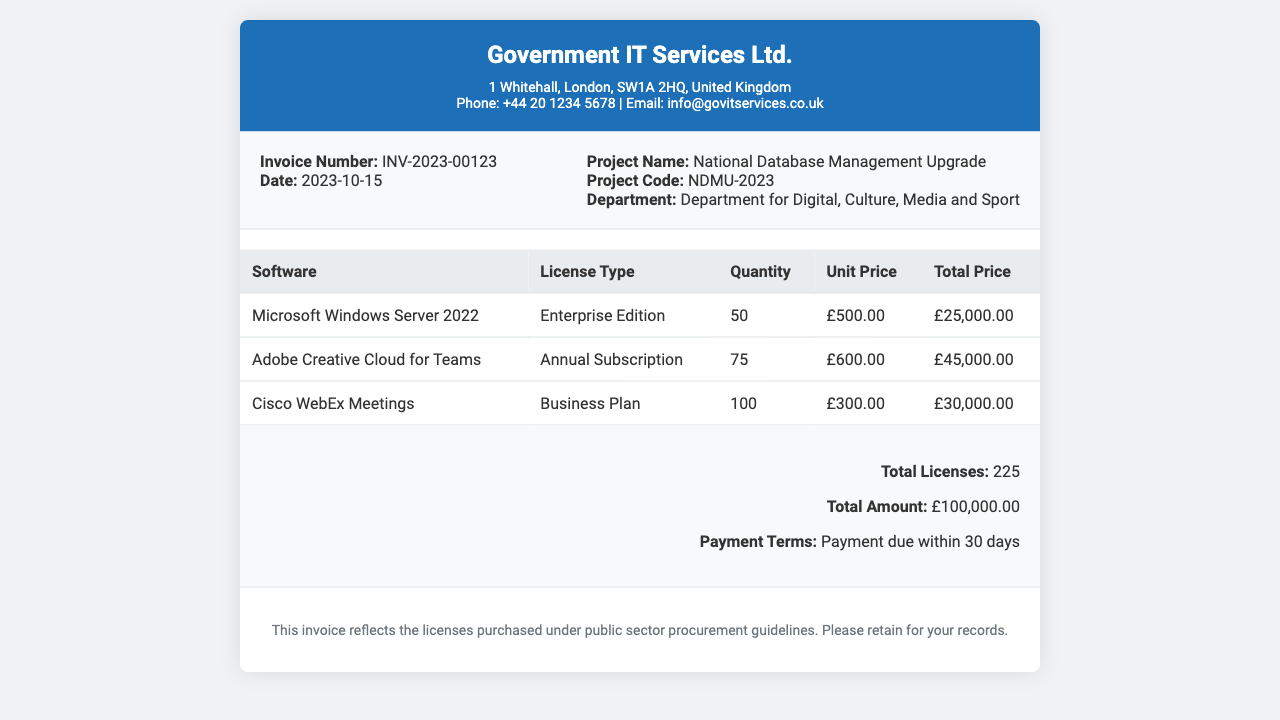What is the invoice number? The invoice number is found in the invoice details section of the document.
Answer: INV-2023-00123 What is the total amount for the licenses? The total amount is calculated as the sum of total prices for all software licenses detailed in the table.
Answer: £100,000.00 How many licenses for Adobe Creative Cloud for Teams were purchased? The quantity of Adobe Creative Cloud for Teams is specified in the table under the quantity column.
Answer: 75 What is the project name associated with this invoice? The project name is listed in the invoice details section.
Answer: National Database Management Upgrade What is the payment term for this invoice? The payment term is mentioned in the summary section at the bottom of the document.
Answer: Payment due within 30 days How many software licenses are detailed in total? The total licenses count can be found summed up in the summary section of the document.
Answer: 225 What is the license type for Cisco WebEx Meetings? The license type for Cisco WebEx Meetings is indicated in the table under the license type column.
Answer: Business Plan When is the invoice date? The date of the invoice is specified in the invoice details area.
Answer: 2023-10-15 